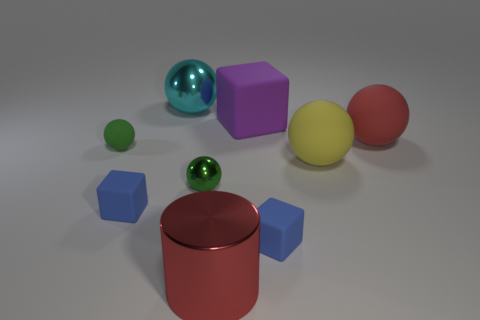Subtract all balls. How many objects are left? 4 Subtract 4 balls. How many balls are left? 1 Subtract all purple cubes. How many cubes are left? 2 Subtract all purple rubber cubes. How many cubes are left? 2 Subtract 0 gray cylinders. How many objects are left? 9 Subtract all yellow blocks. Subtract all red balls. How many blocks are left? 3 Subtract all red cylinders. How many blue blocks are left? 2 Subtract all large cyan rubber cylinders. Subtract all cyan metal spheres. How many objects are left? 8 Add 5 yellow spheres. How many yellow spheres are left? 6 Add 1 tiny green matte spheres. How many tiny green matte spheres exist? 2 